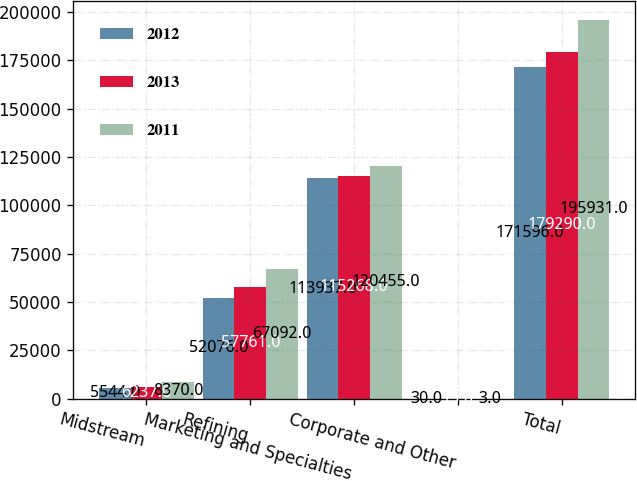<chart> <loc_0><loc_0><loc_500><loc_500><stacked_bar_chart><ecel><fcel>Midstream<fcel>Refining<fcel>Marketing and Specialties<fcel>Corporate and Other<fcel>Total<nl><fcel>2012<fcel>5544<fcel>52076<fcel>113937<fcel>30<fcel>171596<nl><fcel>2013<fcel>6237<fcel>57761<fcel>115268<fcel>13<fcel>179290<nl><fcel>2011<fcel>8370<fcel>67092<fcel>120455<fcel>3<fcel>195931<nl></chart> 